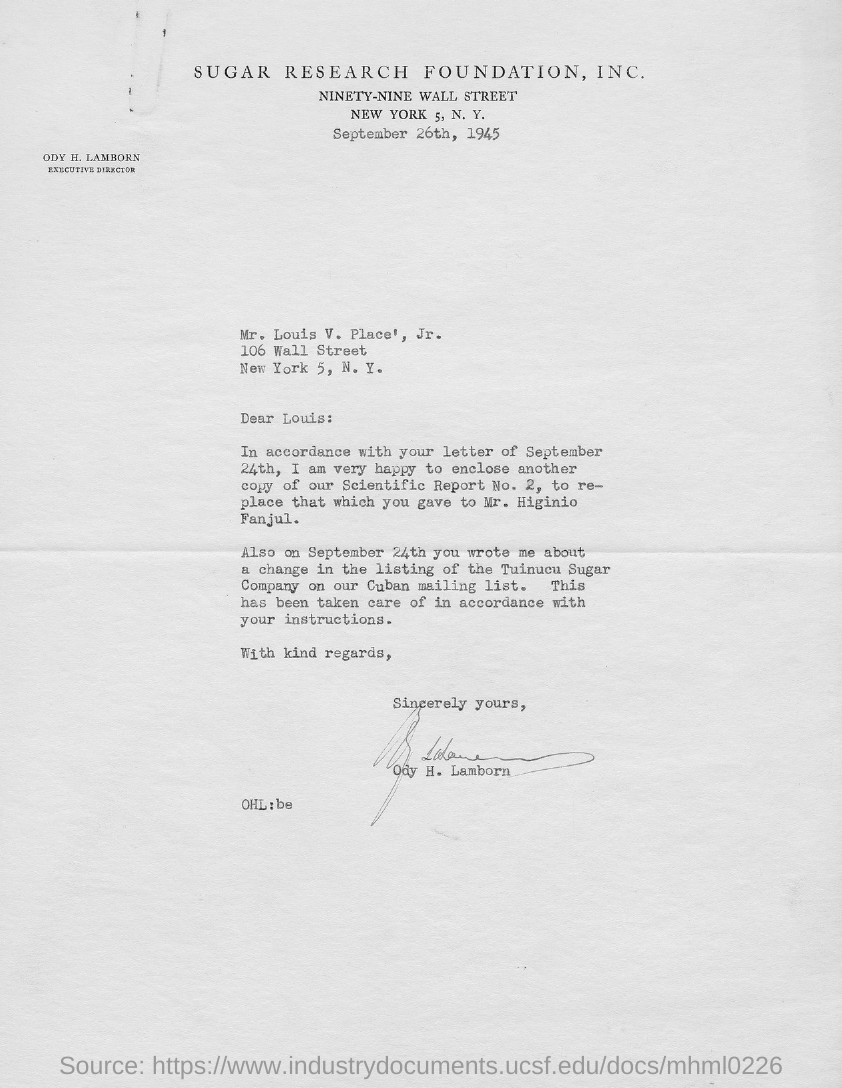What is the position of ody h. lamborn?
Offer a very short reply. Executive Director. When is the letter dated ?
Your answer should be compact. September 26th, 1945. 